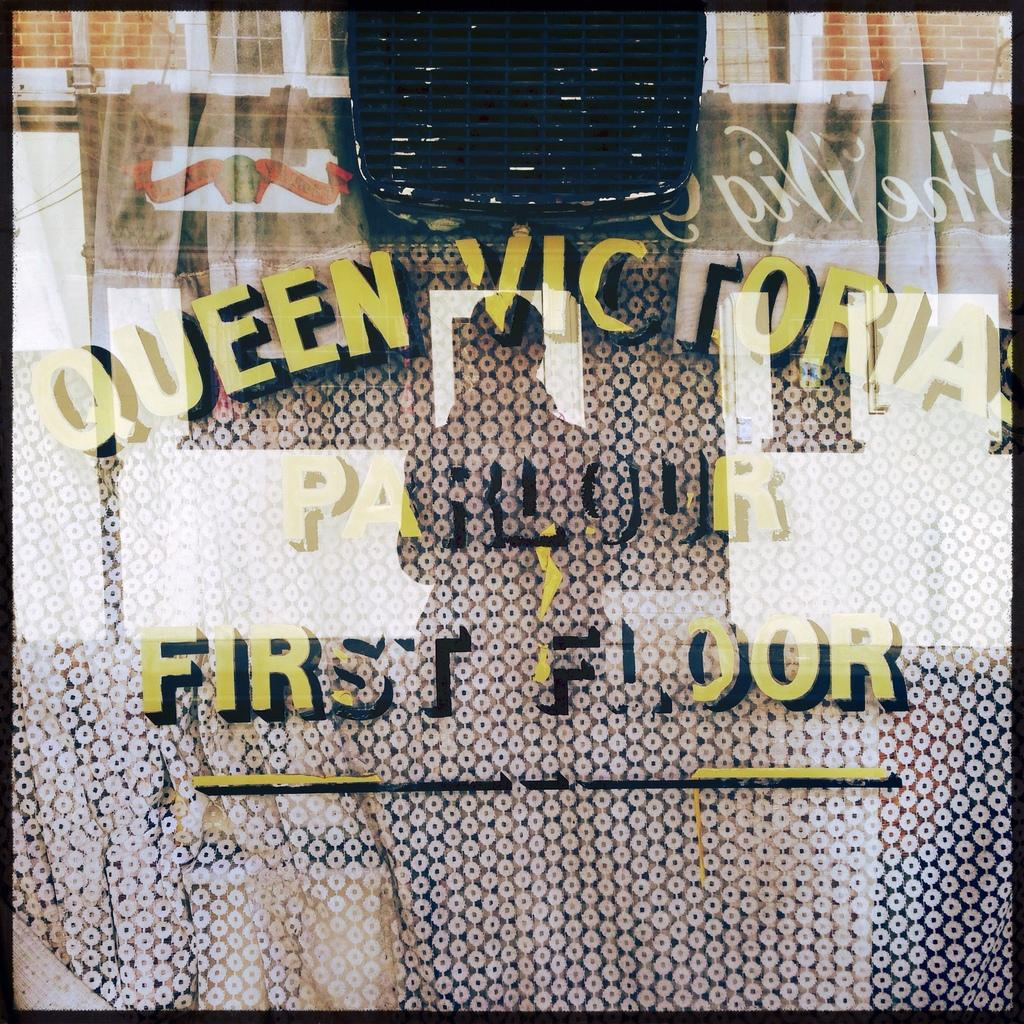<image>
Render a clear and concise summary of the photo. The name of the Queen Victoria parlour is etched in painting black and yellow paint on a window. 